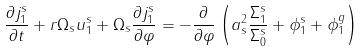<formula> <loc_0><loc_0><loc_500><loc_500>\frac { \partial j _ { 1 } ^ { s } } { \partial t } + r \Omega _ { s } u _ { 1 } ^ { s } + \Omega _ { s } \frac { \partial j _ { 1 } ^ { s } } { \partial \varphi } = - \frac { \partial } { \partial \varphi } \left ( a _ { s } ^ { 2 } \frac { \Sigma _ { 1 } ^ { s } } { \Sigma _ { 0 } ^ { s } } + \phi _ { 1 } ^ { s } + \phi _ { 1 } ^ { g } \right )</formula> 